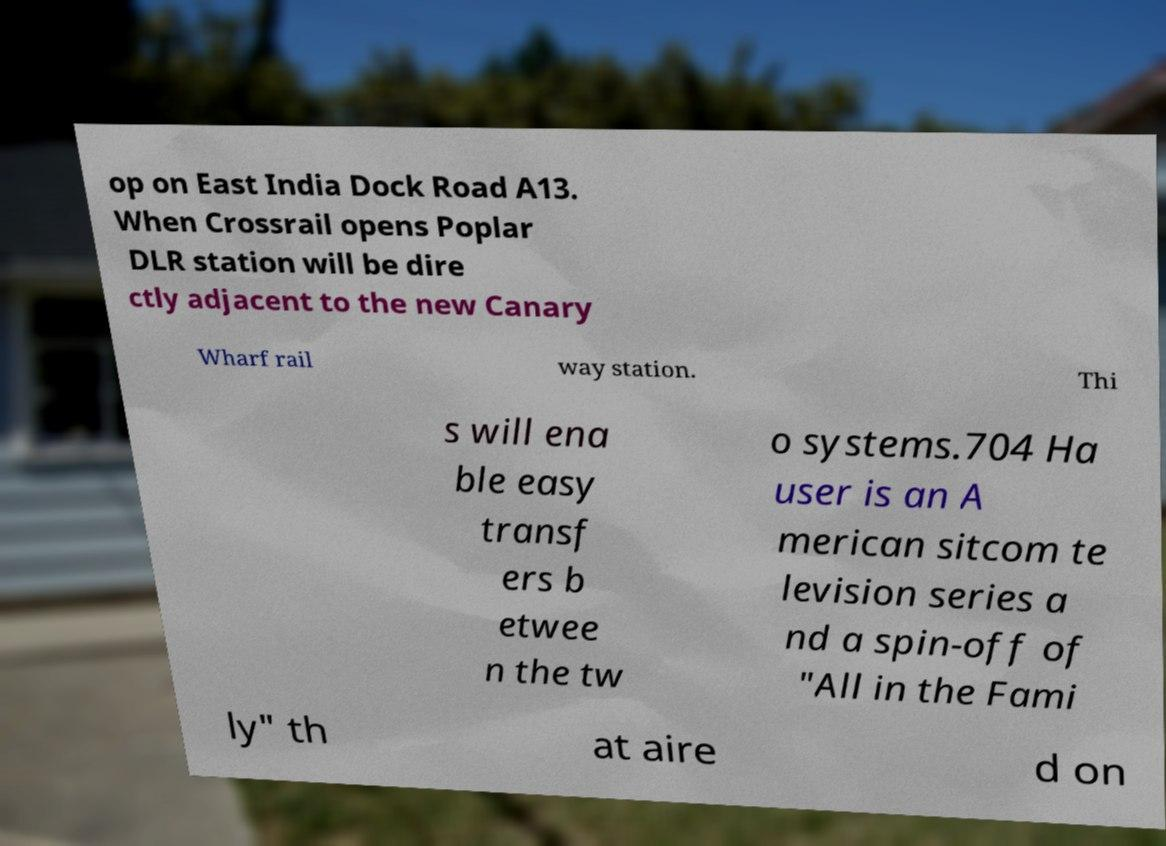Please identify and transcribe the text found in this image. op on East India Dock Road A13. When Crossrail opens Poplar DLR station will be dire ctly adjacent to the new Canary Wharf rail way station. Thi s will ena ble easy transf ers b etwee n the tw o systems.704 Ha user is an A merican sitcom te levision series a nd a spin-off of "All in the Fami ly" th at aire d on 